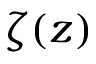Convert formula to latex. <formula><loc_0><loc_0><loc_500><loc_500>\zeta ( z )</formula> 